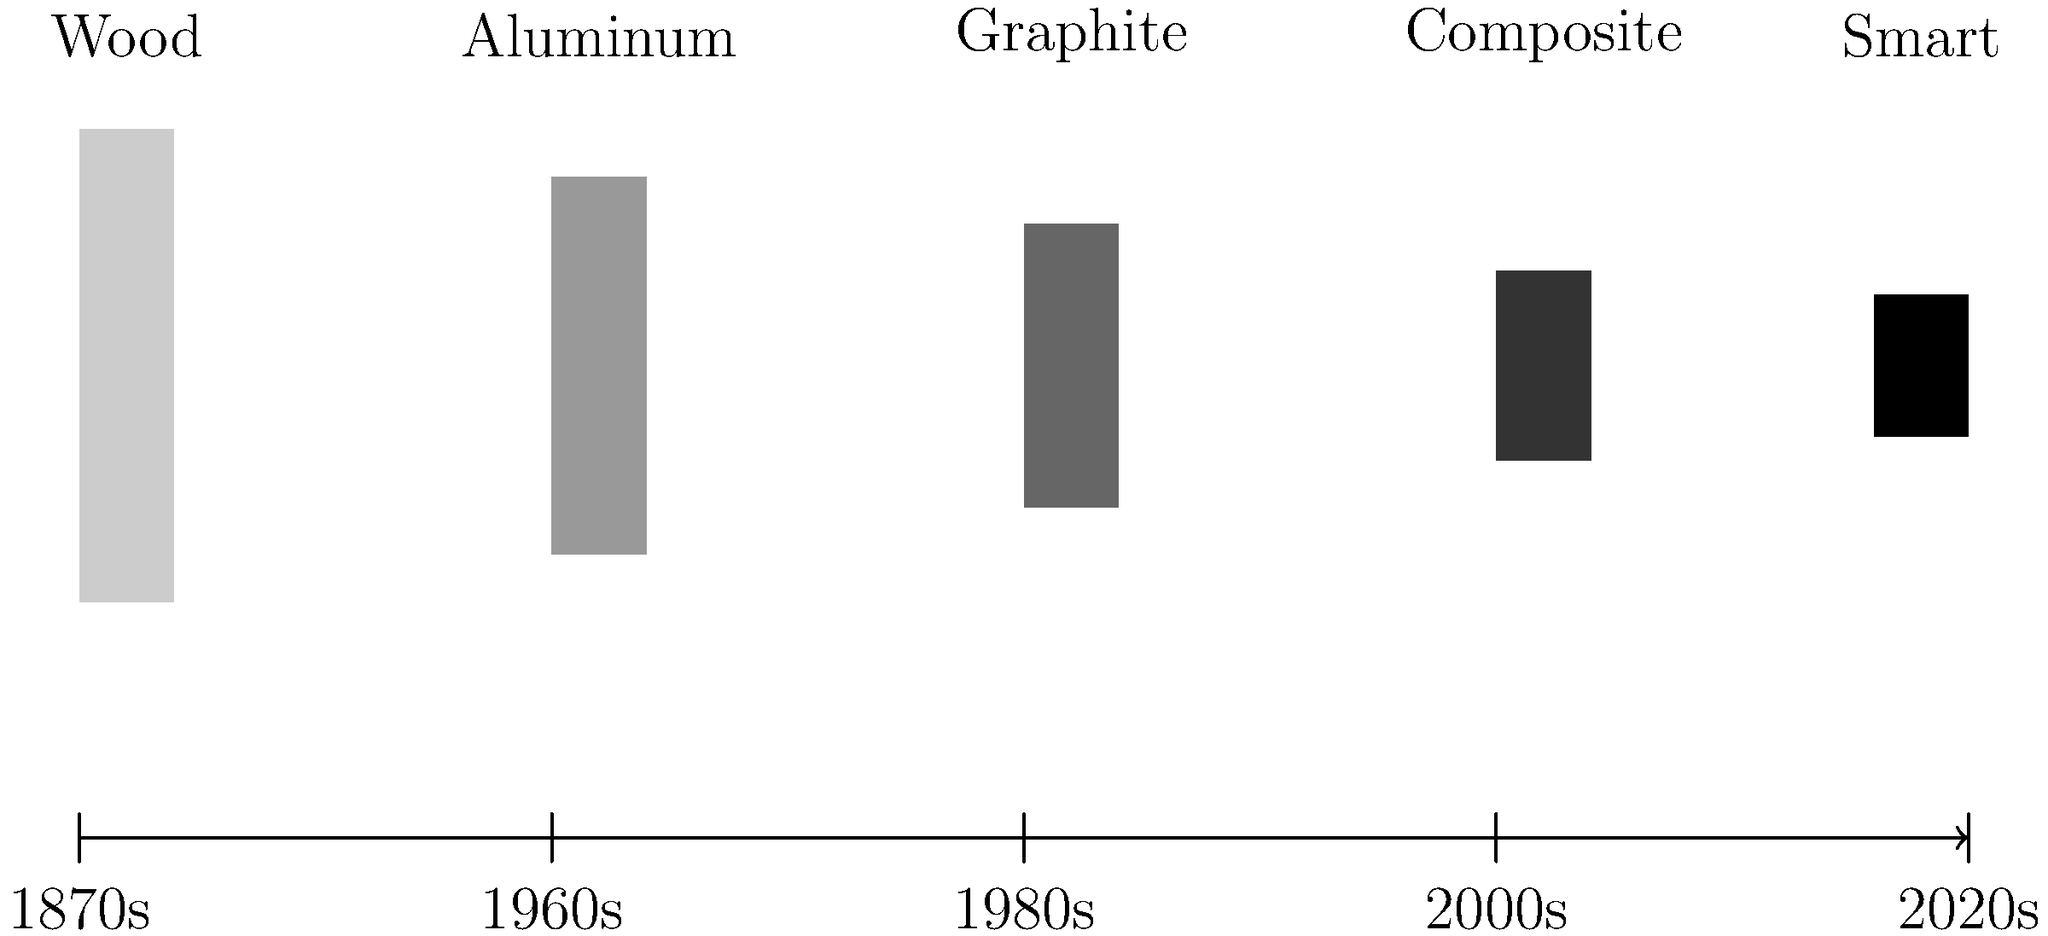Analyze the progression of tennis racket technology as depicted in the timeline. Which material represented a significant shift in racket design during the 1980s, and how did it impact the sport? To answer this question, let's examine the progression of tennis racket technology step-by-step:

1. 1870s: Wood rackets were the standard. They were heavy and had small head sizes, limiting power and control.

2. 1960s: Aluminum rackets were introduced. They were lighter than wood but still had limitations in terms of flexibility and power generation.

3. 1980s: Graphite rackets emerged, representing a significant shift in racket design. This is the key period for our answer.

4. 2000s: Composite materials became popular, combining graphite with other materials for improved performance.

5. 2020s: Smart rackets with embedded sensors for data collection are being developed.

The significant shift in the 1980s was the introduction of graphite rackets. This impacted the sport in several ways:

a) Increased power: Graphite allowed for larger head sizes without adding weight, increasing the sweet spot and power potential.

b) Improved control: The material's stiffness and lightweight properties enhanced players' ability to control the ball.

c) Enhanced spin: The larger head size and string pattern variations made possible by graphite allowed players to generate more spin.

d) Changed playing styles: The additional power and control led to faster-paced games and enabled players to hit with more topspin from the baseline.

e) Accessibility: The durability and performance of graphite rackets made high-quality equipment more accessible to amateur players.
Answer: Graphite; increased power, control, and spin, changing playing styles and making high-performance rackets more accessible. 